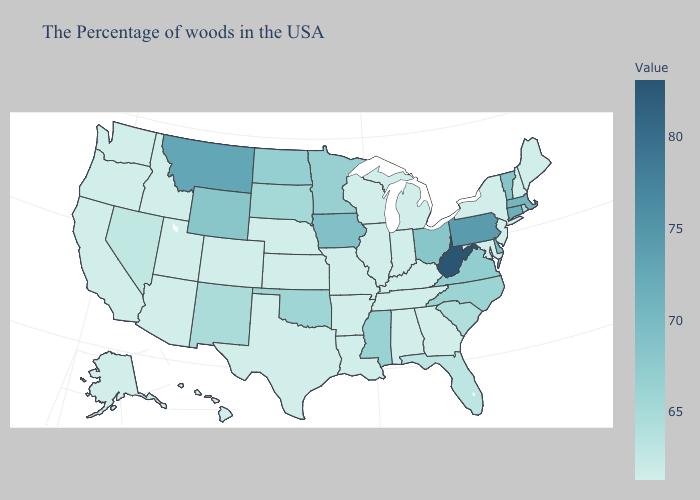Does Iowa have the highest value in the MidWest?
Answer briefly. Yes. Among the states that border Kentucky , does Indiana have the highest value?
Short answer required. No. Does Kansas have the lowest value in the USA?
Concise answer only. Yes. Is the legend a continuous bar?
Concise answer only. Yes. Does the map have missing data?
Short answer required. No. Is the legend a continuous bar?
Answer briefly. Yes. Which states have the lowest value in the USA?
Write a very short answer. Maine, New Hampshire, New York, New Jersey, Maryland, Georgia, Michigan, Kentucky, Indiana, Alabama, Tennessee, Wisconsin, Illinois, Louisiana, Missouri, Arkansas, Kansas, Nebraska, Texas, Colorado, Utah, Arizona, Idaho, California, Washington, Oregon, Alaska, Hawaii. Does Rhode Island have the lowest value in the Northeast?
Write a very short answer. No. Does Hawaii have a higher value than West Virginia?
Write a very short answer. No. Does North Carolina have the lowest value in the USA?
Keep it brief. No. Which states have the lowest value in the South?
Keep it brief. Maryland, Georgia, Kentucky, Alabama, Tennessee, Louisiana, Arkansas, Texas. Among the states that border North Carolina , which have the highest value?
Write a very short answer. Virginia. 